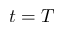Convert formula to latex. <formula><loc_0><loc_0><loc_500><loc_500>t = T</formula> 